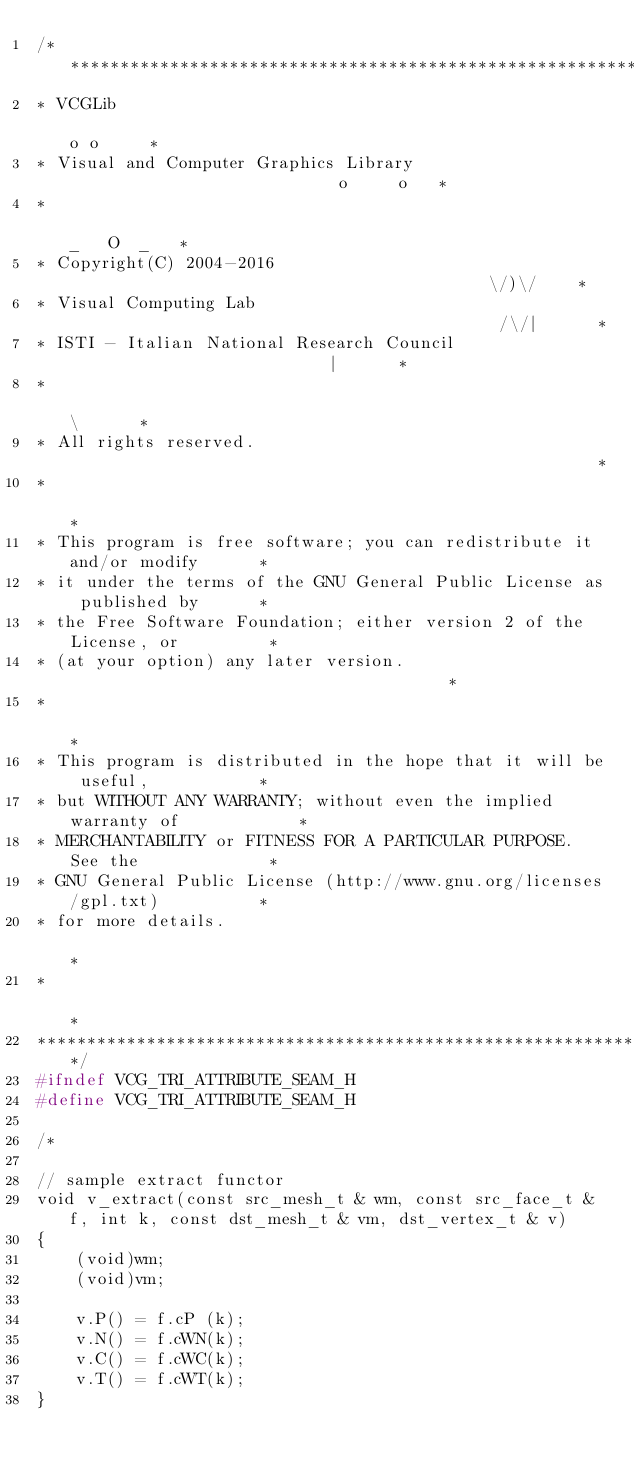<code> <loc_0><loc_0><loc_500><loc_500><_C_>/****************************************************************************
* VCGLib                                                            o o     *
* Visual and Computer Graphics Library                            o     o   *
*                                                                _   O  _   *
* Copyright(C) 2004-2016                                           \/)\/    *
* Visual Computing Lab                                            /\/|      *
* ISTI - Italian National Research Council                           |      *
*                                                                    \      *
* All rights reserved.                                                      *
*                                                                           *
* This program is free software; you can redistribute it and/or modify      *
* it under the terms of the GNU General Public License as published by      *
* the Free Software Foundation; either version 2 of the License, or         *
* (at your option) any later version.                                       *
*                                                                           *
* This program is distributed in the hope that it will be useful,           *
* but WITHOUT ANY WARRANTY; without even the implied warranty of            *
* MERCHANTABILITY or FITNESS FOR A PARTICULAR PURPOSE.  See the             *
* GNU General Public License (http://www.gnu.org/licenses/gpl.txt)          *
* for more details.                                                         *
*                                                                           *
****************************************************************************/
#ifndef VCG_TRI_ATTRIBUTE_SEAM_H
#define VCG_TRI_ATTRIBUTE_SEAM_H

/*

// sample extract functor
void v_extract(const src_mesh_t & wm, const src_face_t & f, int k, const dst_mesh_t & vm, dst_vertex_t & v)
{
    (void)wm;
    (void)vm;

    v.P() = f.cP (k);
    v.N() = f.cWN(k);
    v.C() = f.cWC(k);
    v.T() = f.cWT(k);
}
</code> 